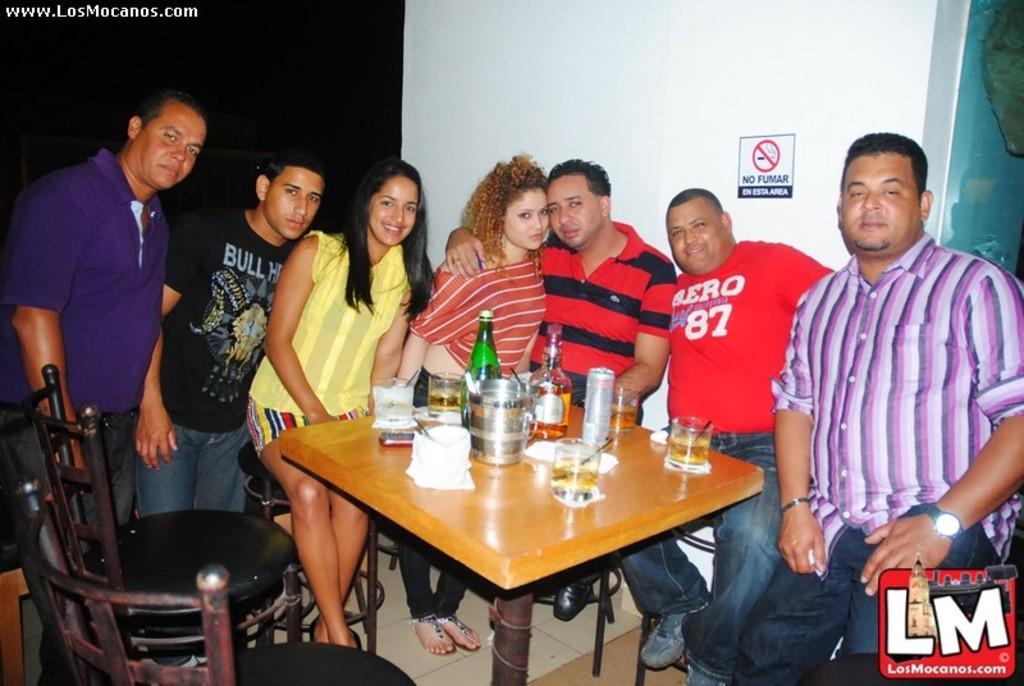Could you give a brief overview of what you see in this image? In this image i can see sitting on chair, there are few glasses, bottle, paper on a table, at the back ground i can see a board and a wall. 